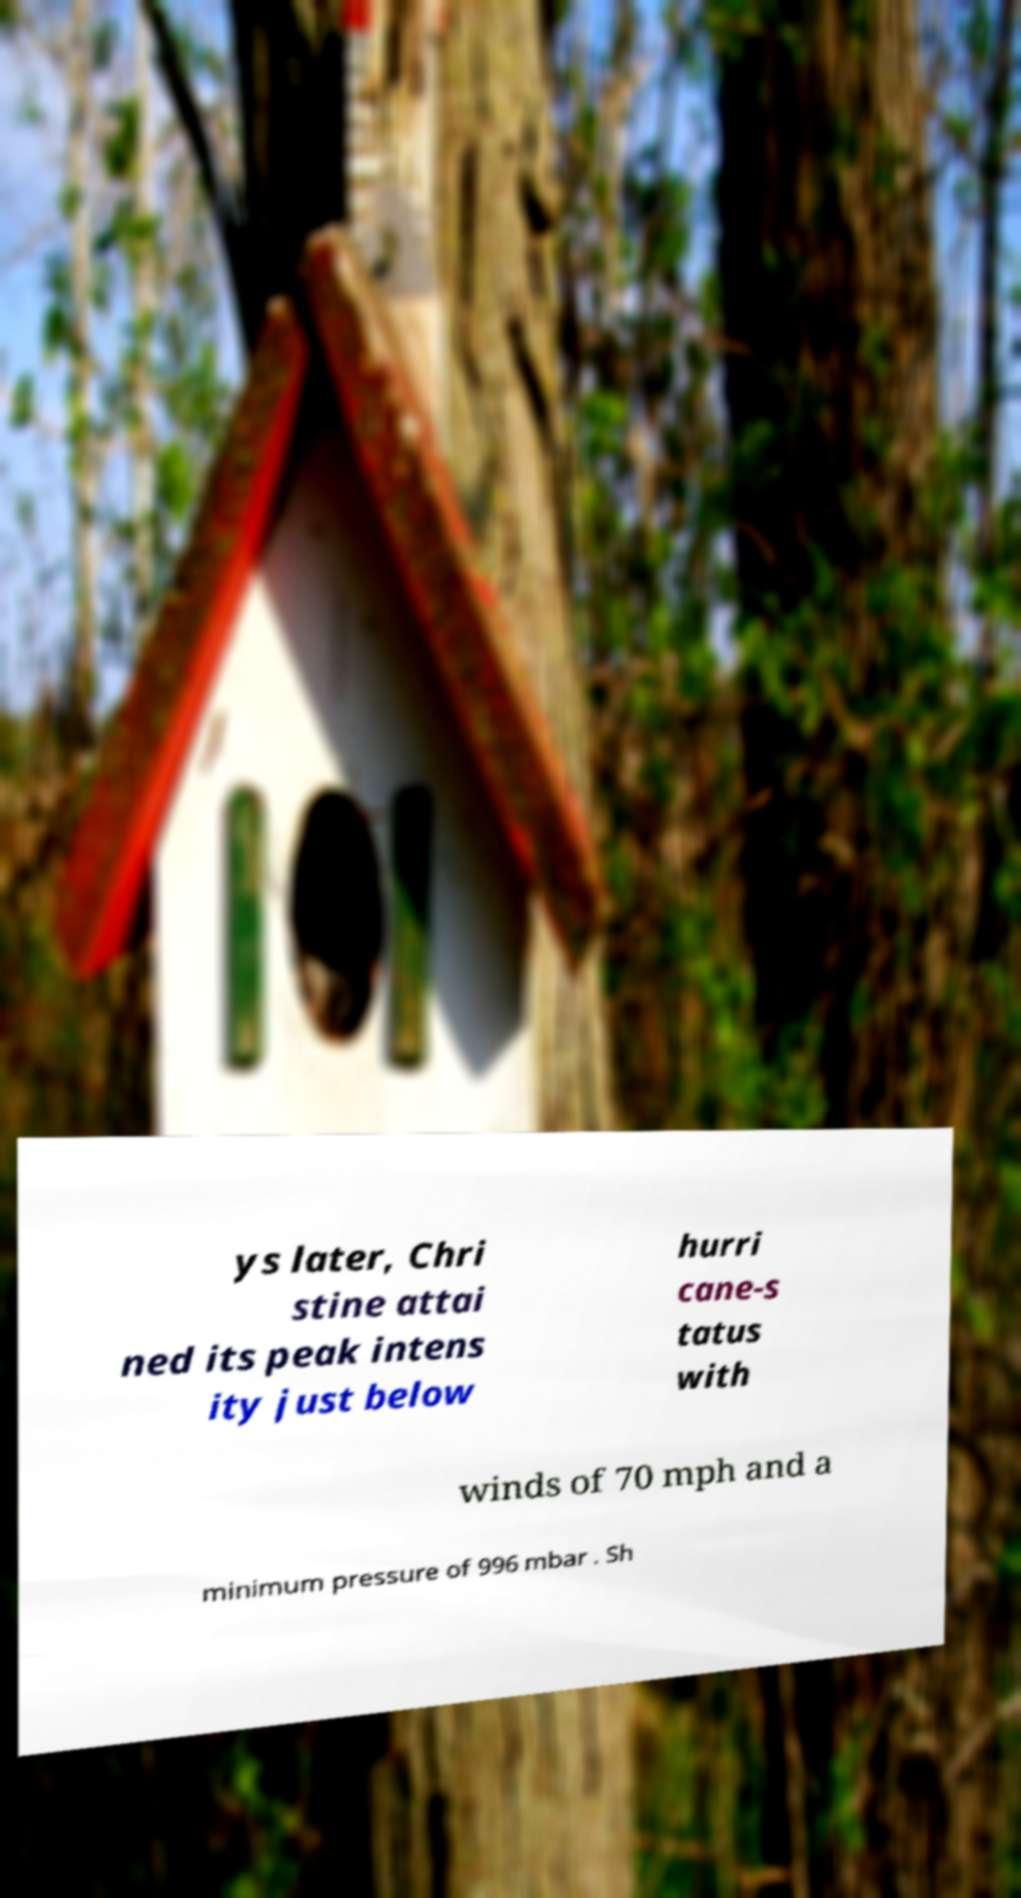Please identify and transcribe the text found in this image. ys later, Chri stine attai ned its peak intens ity just below hurri cane-s tatus with winds of 70 mph and a minimum pressure of 996 mbar . Sh 